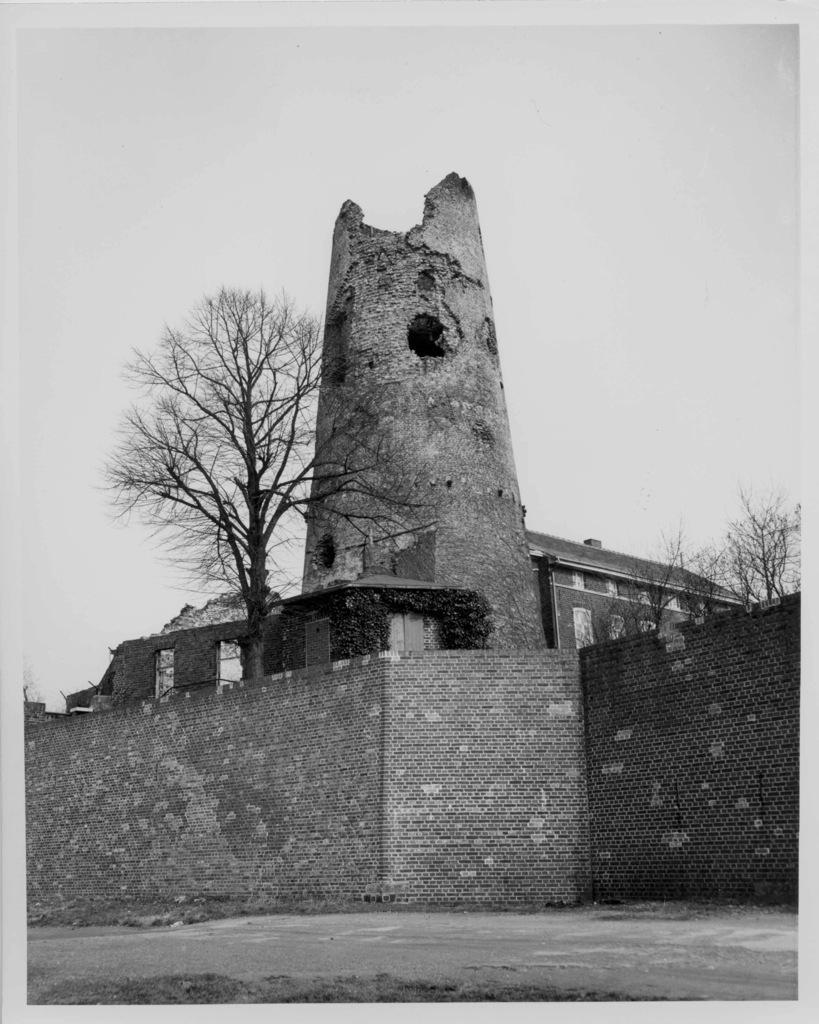Can you describe this image briefly? In the foreground of this picture, there is a wall and a building, trees and the sky. 